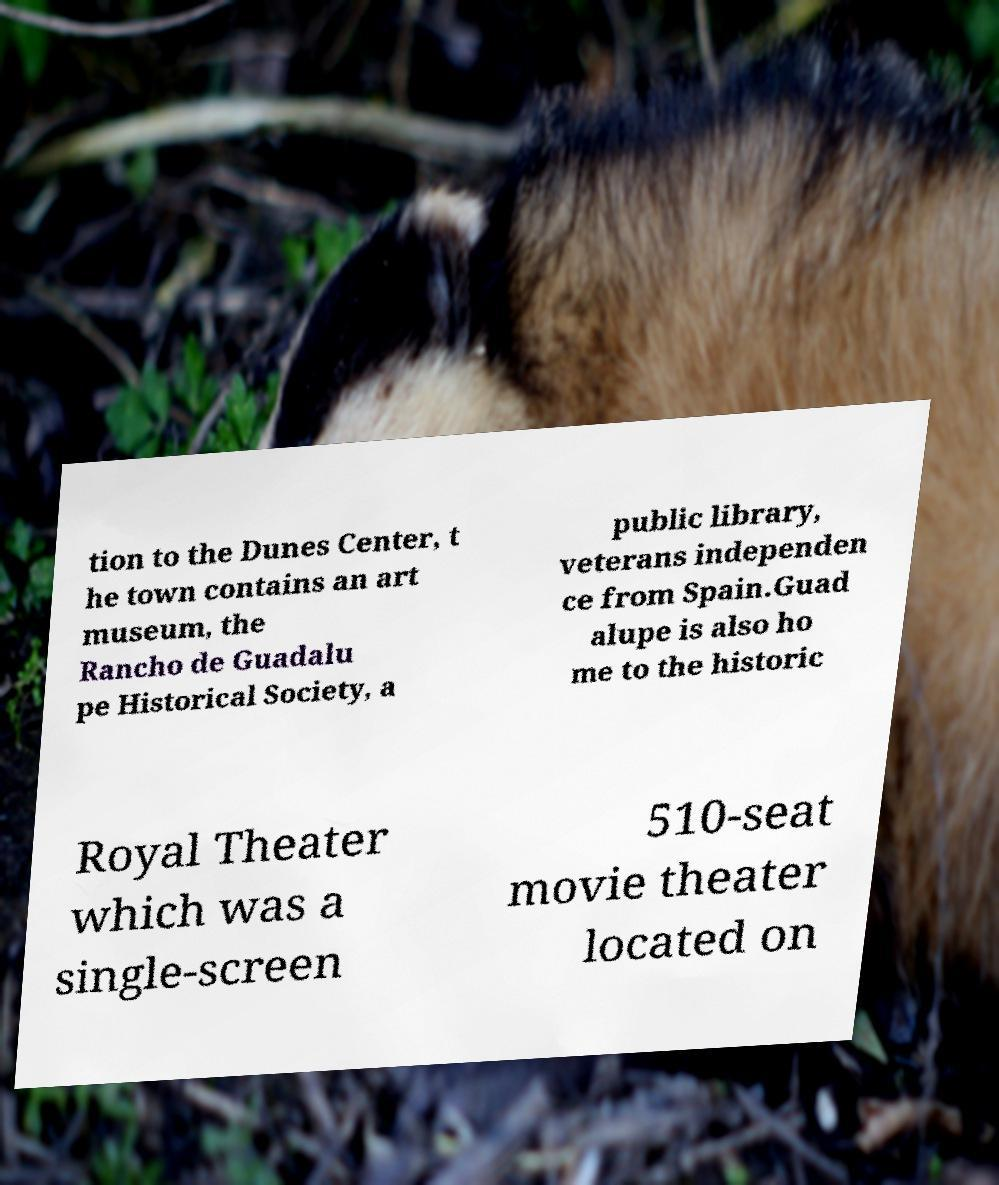Could you assist in decoding the text presented in this image and type it out clearly? tion to the Dunes Center, t he town contains an art museum, the Rancho de Guadalu pe Historical Society, a public library, veterans independen ce from Spain.Guad alupe is also ho me to the historic Royal Theater which was a single-screen 510-seat movie theater located on 